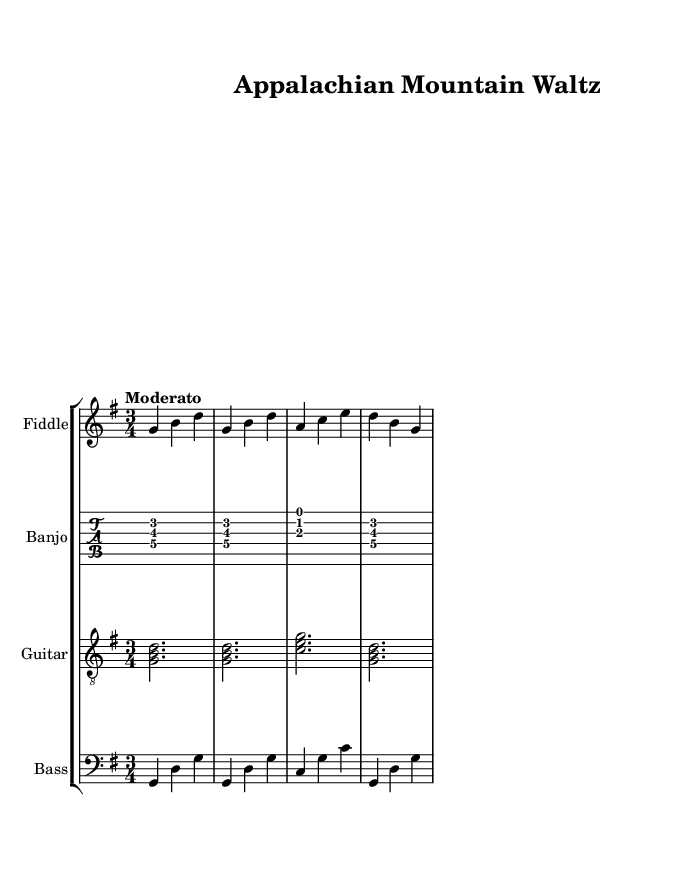What is the title of this piece? The title is indicated at the top of the sheet music in the header section.
Answer: Appalachian Mountain Waltz What is the time signature of this music? The time signature is found at the beginning of the score, showing three beats in each measure.
Answer: 3/4 What is the key signature of this music? The key signature is specified alongside the clef at the beginning, showing one sharp which indicates G major.
Answer: G major What is the tempo marking for this piece? The tempo marking indicates the pace at which the music should be played and can be found under the time signature.
Answer: Moderato How many instruments are featured in this score? By counting the number of staves in the score section, you can determine the total number of instruments.
Answer: Four Which instrument is indicated to play the melody? The melody is typically played by the instrument shown at the top of the staves; in this case, it is the fiddle.
Answer: Fiddle What is the role of the bass in this piece? The bass provides harmonic support, and its part can be identified in the score by examining its notes in relation to the other instruments.
Answer: Harmonic support 